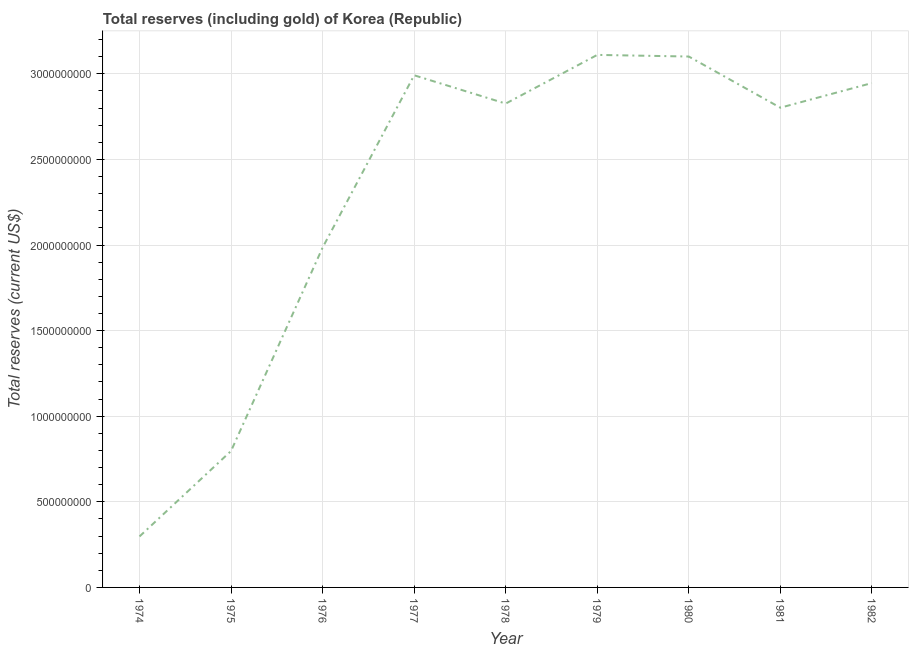What is the total reserves (including gold) in 1982?
Your response must be concise. 2.95e+09. Across all years, what is the maximum total reserves (including gold)?
Provide a succinct answer. 3.11e+09. Across all years, what is the minimum total reserves (including gold)?
Give a very brief answer. 2.98e+08. In which year was the total reserves (including gold) maximum?
Give a very brief answer. 1979. In which year was the total reserves (including gold) minimum?
Offer a terse response. 1974. What is the sum of the total reserves (including gold)?
Keep it short and to the point. 2.09e+1. What is the difference between the total reserves (including gold) in 1976 and 1979?
Offer a very short reply. -1.13e+09. What is the average total reserves (including gold) per year?
Give a very brief answer. 2.32e+09. What is the median total reserves (including gold)?
Your answer should be very brief. 2.83e+09. In how many years, is the total reserves (including gold) greater than 2000000000 US$?
Provide a succinct answer. 6. What is the ratio of the total reserves (including gold) in 1977 to that in 1982?
Offer a very short reply. 1.02. Is the difference between the total reserves (including gold) in 1980 and 1982 greater than the difference between any two years?
Your answer should be compact. No. What is the difference between the highest and the second highest total reserves (including gold)?
Offer a very short reply. 9.52e+06. What is the difference between the highest and the lowest total reserves (including gold)?
Offer a very short reply. 2.81e+09. Does the total reserves (including gold) monotonically increase over the years?
Your answer should be compact. No. How many years are there in the graph?
Provide a succinct answer. 9. Are the values on the major ticks of Y-axis written in scientific E-notation?
Give a very brief answer. No. Does the graph contain grids?
Provide a succinct answer. Yes. What is the title of the graph?
Provide a short and direct response. Total reserves (including gold) of Korea (Republic). What is the label or title of the X-axis?
Your response must be concise. Year. What is the label or title of the Y-axis?
Keep it short and to the point. Total reserves (current US$). What is the Total reserves (current US$) of 1974?
Offer a terse response. 2.98e+08. What is the Total reserves (current US$) of 1975?
Your answer should be compact. 7.97e+08. What is the Total reserves (current US$) of 1976?
Ensure brevity in your answer.  1.99e+09. What is the Total reserves (current US$) in 1977?
Make the answer very short. 2.99e+09. What is the Total reserves (current US$) of 1978?
Keep it short and to the point. 2.83e+09. What is the Total reserves (current US$) of 1979?
Keep it short and to the point. 3.11e+09. What is the Total reserves (current US$) in 1980?
Your answer should be very brief. 3.10e+09. What is the Total reserves (current US$) of 1981?
Your answer should be very brief. 2.80e+09. What is the Total reserves (current US$) in 1982?
Make the answer very short. 2.95e+09. What is the difference between the Total reserves (current US$) in 1974 and 1975?
Provide a succinct answer. -4.99e+08. What is the difference between the Total reserves (current US$) in 1974 and 1976?
Keep it short and to the point. -1.69e+09. What is the difference between the Total reserves (current US$) in 1974 and 1977?
Ensure brevity in your answer.  -2.69e+09. What is the difference between the Total reserves (current US$) in 1974 and 1978?
Give a very brief answer. -2.53e+09. What is the difference between the Total reserves (current US$) in 1974 and 1979?
Give a very brief answer. -2.81e+09. What is the difference between the Total reserves (current US$) in 1974 and 1980?
Provide a succinct answer. -2.80e+09. What is the difference between the Total reserves (current US$) in 1974 and 1981?
Provide a succinct answer. -2.50e+09. What is the difference between the Total reserves (current US$) in 1974 and 1982?
Your answer should be very brief. -2.65e+09. What is the difference between the Total reserves (current US$) in 1975 and 1976?
Keep it short and to the point. -1.19e+09. What is the difference between the Total reserves (current US$) in 1975 and 1977?
Make the answer very short. -2.19e+09. What is the difference between the Total reserves (current US$) in 1975 and 1978?
Your answer should be compact. -2.03e+09. What is the difference between the Total reserves (current US$) in 1975 and 1979?
Your answer should be very brief. -2.31e+09. What is the difference between the Total reserves (current US$) in 1975 and 1980?
Your answer should be compact. -2.30e+09. What is the difference between the Total reserves (current US$) in 1975 and 1981?
Give a very brief answer. -2.01e+09. What is the difference between the Total reserves (current US$) in 1975 and 1982?
Ensure brevity in your answer.  -2.15e+09. What is the difference between the Total reserves (current US$) in 1976 and 1977?
Offer a terse response. -1.01e+09. What is the difference between the Total reserves (current US$) in 1976 and 1978?
Provide a short and direct response. -8.41e+08. What is the difference between the Total reserves (current US$) in 1976 and 1979?
Your response must be concise. -1.13e+09. What is the difference between the Total reserves (current US$) in 1976 and 1980?
Provide a succinct answer. -1.12e+09. What is the difference between the Total reserves (current US$) in 1976 and 1981?
Your answer should be compact. -8.17e+08. What is the difference between the Total reserves (current US$) in 1976 and 1982?
Your response must be concise. -9.61e+08. What is the difference between the Total reserves (current US$) in 1977 and 1978?
Your answer should be compact. 1.65e+08. What is the difference between the Total reserves (current US$) in 1977 and 1979?
Give a very brief answer. -1.19e+08. What is the difference between the Total reserves (current US$) in 1977 and 1980?
Keep it short and to the point. -1.09e+08. What is the difference between the Total reserves (current US$) in 1977 and 1981?
Provide a short and direct response. 1.89e+08. What is the difference between the Total reserves (current US$) in 1977 and 1982?
Provide a succinct answer. 4.55e+07. What is the difference between the Total reserves (current US$) in 1978 and 1979?
Ensure brevity in your answer.  -2.84e+08. What is the difference between the Total reserves (current US$) in 1978 and 1980?
Make the answer very short. -2.75e+08. What is the difference between the Total reserves (current US$) in 1978 and 1981?
Provide a succinct answer. 2.40e+07. What is the difference between the Total reserves (current US$) in 1978 and 1982?
Provide a short and direct response. -1.20e+08. What is the difference between the Total reserves (current US$) in 1979 and 1980?
Provide a short and direct response. 9.52e+06. What is the difference between the Total reserves (current US$) in 1979 and 1981?
Your answer should be compact. 3.08e+08. What is the difference between the Total reserves (current US$) in 1979 and 1982?
Your answer should be very brief. 1.65e+08. What is the difference between the Total reserves (current US$) in 1980 and 1981?
Give a very brief answer. 2.99e+08. What is the difference between the Total reserves (current US$) in 1980 and 1982?
Keep it short and to the point. 1.55e+08. What is the difference between the Total reserves (current US$) in 1981 and 1982?
Your response must be concise. -1.44e+08. What is the ratio of the Total reserves (current US$) in 1974 to that in 1975?
Make the answer very short. 0.37. What is the ratio of the Total reserves (current US$) in 1974 to that in 1976?
Give a very brief answer. 0.15. What is the ratio of the Total reserves (current US$) in 1974 to that in 1977?
Ensure brevity in your answer.  0.1. What is the ratio of the Total reserves (current US$) in 1974 to that in 1978?
Keep it short and to the point. 0.1. What is the ratio of the Total reserves (current US$) in 1974 to that in 1979?
Your response must be concise. 0.1. What is the ratio of the Total reserves (current US$) in 1974 to that in 1980?
Keep it short and to the point. 0.1. What is the ratio of the Total reserves (current US$) in 1974 to that in 1981?
Your answer should be very brief. 0.11. What is the ratio of the Total reserves (current US$) in 1974 to that in 1982?
Provide a short and direct response. 0.1. What is the ratio of the Total reserves (current US$) in 1975 to that in 1976?
Offer a very short reply. 0.4. What is the ratio of the Total reserves (current US$) in 1975 to that in 1977?
Your answer should be compact. 0.27. What is the ratio of the Total reserves (current US$) in 1975 to that in 1978?
Your response must be concise. 0.28. What is the ratio of the Total reserves (current US$) in 1975 to that in 1979?
Your response must be concise. 0.26. What is the ratio of the Total reserves (current US$) in 1975 to that in 1980?
Provide a succinct answer. 0.26. What is the ratio of the Total reserves (current US$) in 1975 to that in 1981?
Offer a very short reply. 0.28. What is the ratio of the Total reserves (current US$) in 1975 to that in 1982?
Offer a very short reply. 0.27. What is the ratio of the Total reserves (current US$) in 1976 to that in 1977?
Ensure brevity in your answer.  0.66. What is the ratio of the Total reserves (current US$) in 1976 to that in 1978?
Offer a terse response. 0.7. What is the ratio of the Total reserves (current US$) in 1976 to that in 1979?
Provide a short and direct response. 0.64. What is the ratio of the Total reserves (current US$) in 1976 to that in 1980?
Your answer should be very brief. 0.64. What is the ratio of the Total reserves (current US$) in 1976 to that in 1981?
Provide a succinct answer. 0.71. What is the ratio of the Total reserves (current US$) in 1976 to that in 1982?
Keep it short and to the point. 0.67. What is the ratio of the Total reserves (current US$) in 1977 to that in 1978?
Your answer should be very brief. 1.06. What is the ratio of the Total reserves (current US$) in 1977 to that in 1981?
Provide a succinct answer. 1.07. What is the ratio of the Total reserves (current US$) in 1977 to that in 1982?
Make the answer very short. 1.01. What is the ratio of the Total reserves (current US$) in 1978 to that in 1979?
Give a very brief answer. 0.91. What is the ratio of the Total reserves (current US$) in 1978 to that in 1980?
Your response must be concise. 0.91. What is the ratio of the Total reserves (current US$) in 1978 to that in 1982?
Make the answer very short. 0.96. What is the ratio of the Total reserves (current US$) in 1979 to that in 1980?
Your answer should be compact. 1. What is the ratio of the Total reserves (current US$) in 1979 to that in 1981?
Ensure brevity in your answer.  1.11. What is the ratio of the Total reserves (current US$) in 1979 to that in 1982?
Your answer should be very brief. 1.06. What is the ratio of the Total reserves (current US$) in 1980 to that in 1981?
Make the answer very short. 1.11. What is the ratio of the Total reserves (current US$) in 1980 to that in 1982?
Give a very brief answer. 1.05. What is the ratio of the Total reserves (current US$) in 1981 to that in 1982?
Your answer should be very brief. 0.95. 